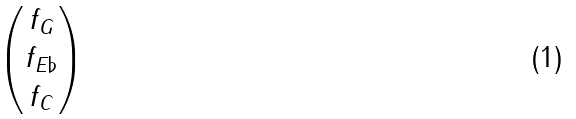Convert formula to latex. <formula><loc_0><loc_0><loc_500><loc_500>\begin{pmatrix} f _ { G } \\ f _ { E \flat } \\ f _ { C } \\ \end{pmatrix}</formula> 